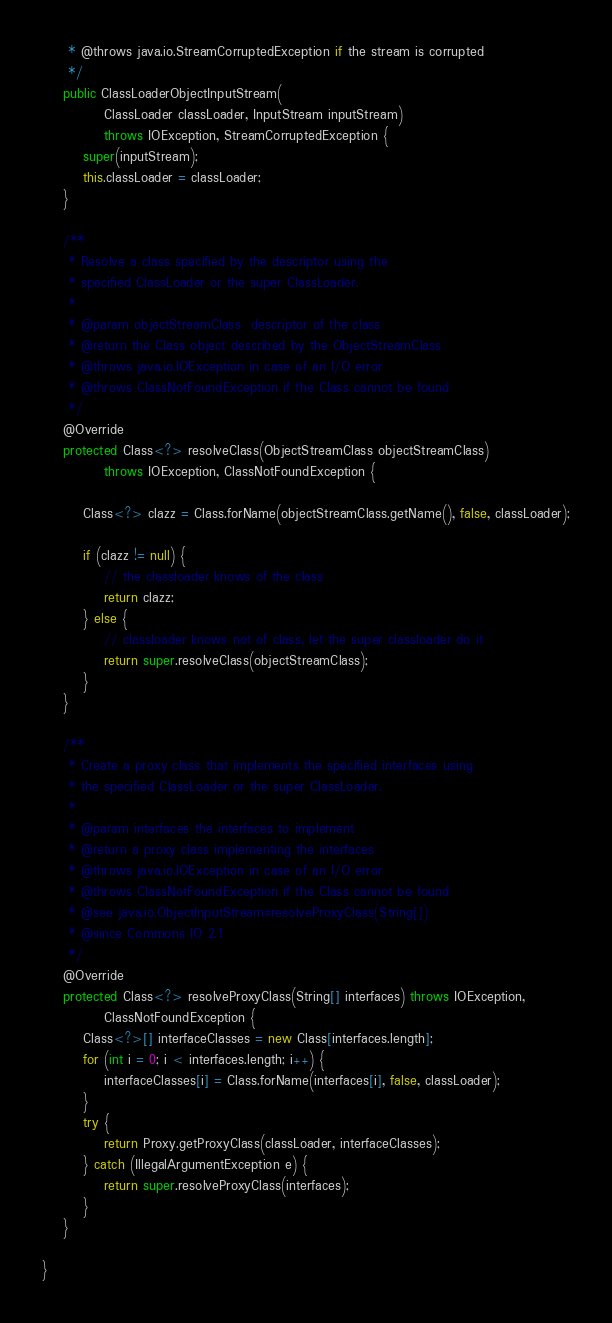Convert code to text. <code><loc_0><loc_0><loc_500><loc_500><_Java_>     * @throws java.io.StreamCorruptedException if the stream is corrupted
     */
    public ClassLoaderObjectInputStream(
            ClassLoader classLoader, InputStream inputStream)
            throws IOException, StreamCorruptedException {
        super(inputStream);
        this.classLoader = classLoader;
    }

    /**
     * Resolve a class specified by the descriptor using the
     * specified ClassLoader or the super ClassLoader.
     *
     * @param objectStreamClass  descriptor of the class
     * @return the Class object described by the ObjectStreamClass
     * @throws java.io.IOException in case of an I/O error
     * @throws ClassNotFoundException if the Class cannot be found
     */
    @Override
    protected Class<?> resolveClass(ObjectStreamClass objectStreamClass)
            throws IOException, ClassNotFoundException {
        
        Class<?> clazz = Class.forName(objectStreamClass.getName(), false, classLoader);

        if (clazz != null) {
            // the classloader knows of the class
            return clazz;
        } else {
            // classloader knows not of class, let the super classloader do it
            return super.resolveClass(objectStreamClass);
        }
    }

    /**
     * Create a proxy class that implements the specified interfaces using
     * the specified ClassLoader or the super ClassLoader.
     *
     * @param interfaces the interfaces to implement
     * @return a proxy class implementing the interfaces
     * @throws java.io.IOException in case of an I/O error
     * @throws ClassNotFoundException if the Class cannot be found
     * @see java.io.ObjectInputStream#resolveProxyClass(String[])
     * @since Commons IO 2.1
     */
    @Override
    protected Class<?> resolveProxyClass(String[] interfaces) throws IOException,
            ClassNotFoundException {
        Class<?>[] interfaceClasses = new Class[interfaces.length];
        for (int i = 0; i < interfaces.length; i++) {
            interfaceClasses[i] = Class.forName(interfaces[i], false, classLoader);
        }
        try {
            return Proxy.getProxyClass(classLoader, interfaceClasses);
        } catch (IllegalArgumentException e) {
            return super.resolveProxyClass(interfaces);
        }
    }
    
}
</code> 